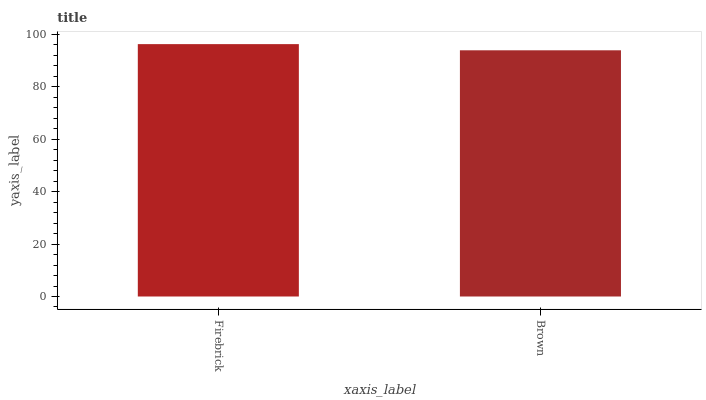Is Brown the maximum?
Answer yes or no. No. Is Firebrick greater than Brown?
Answer yes or no. Yes. Is Brown less than Firebrick?
Answer yes or no. Yes. Is Brown greater than Firebrick?
Answer yes or no. No. Is Firebrick less than Brown?
Answer yes or no. No. Is Firebrick the high median?
Answer yes or no. Yes. Is Brown the low median?
Answer yes or no. Yes. Is Brown the high median?
Answer yes or no. No. Is Firebrick the low median?
Answer yes or no. No. 